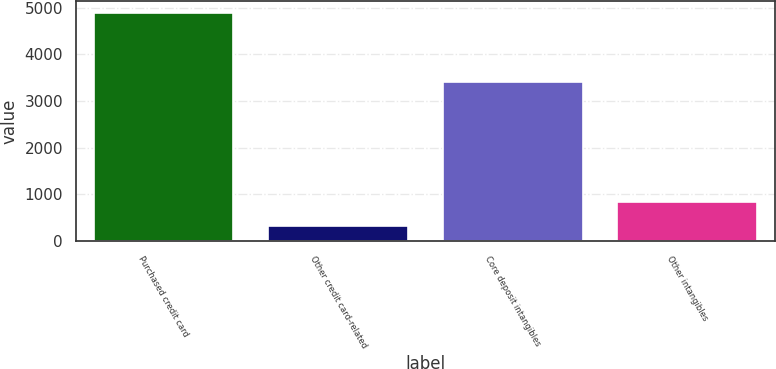Convert chart. <chart><loc_0><loc_0><loc_500><loc_500><bar_chart><fcel>Purchased credit card<fcel>Other credit card-related<fcel>Core deposit intangibles<fcel>Other intangibles<nl><fcel>4892<fcel>314<fcel>3401<fcel>845<nl></chart> 